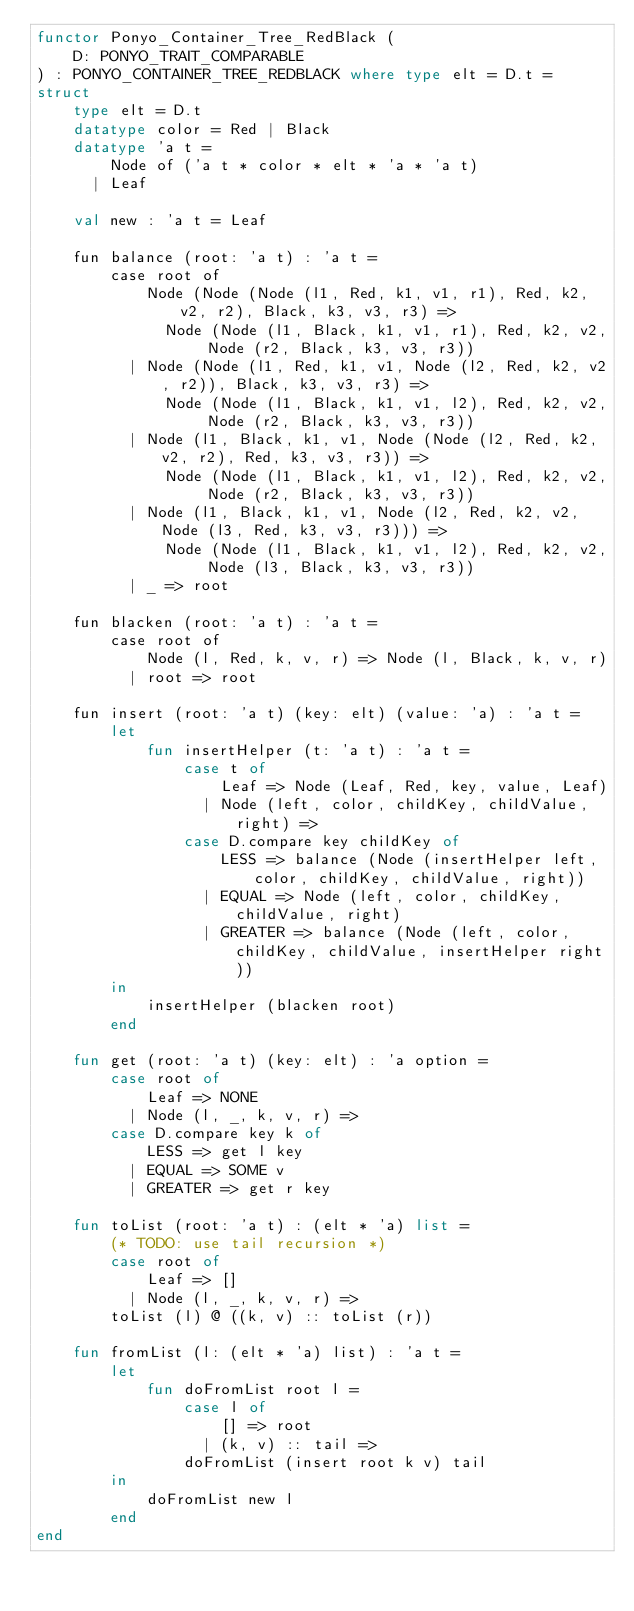<code> <loc_0><loc_0><loc_500><loc_500><_SML_>functor Ponyo_Container_Tree_RedBlack (
    D: PONYO_TRAIT_COMPARABLE
) : PONYO_CONTAINER_TREE_REDBLACK where type elt = D.t =
struct
    type elt = D.t
    datatype color = Red | Black
    datatype 'a t =
        Node of ('a t * color * elt * 'a * 'a t)
      | Leaf

    val new : 'a t = Leaf

    fun balance (root: 'a t) : 'a t =
        case root of
            Node (Node (Node (l1, Red, k1, v1, r1), Red, k2, v2, r2), Black, k3, v3, r3) =>
              Node (Node (l1, Black, k1, v1, r1), Red, k2, v2, Node (r2, Black, k3, v3, r3))
          | Node (Node (l1, Red, k1, v1, Node (l2, Red, k2, v2, r2)), Black, k3, v3, r3) =>
              Node (Node (l1, Black, k1, v1, l2), Red, k2, v2, Node (r2, Black, k3, v3, r3))
          | Node (l1, Black, k1, v1, Node (Node (l2, Red, k2, v2, r2), Red, k3, v3, r3)) =>
              Node (Node (l1, Black, k1, v1, l2), Red, k2, v2, Node (r2, Black, k3, v3, r3))
          | Node (l1, Black, k1, v1, Node (l2, Red, k2, v2, Node (l3, Red, k3, v3, r3))) =>
              Node (Node (l1, Black, k1, v1, l2), Red, k2, v2, Node (l3, Black, k3, v3, r3))
          | _ => root

    fun blacken (root: 'a t) : 'a t =
        case root of
            Node (l, Red, k, v, r) => Node (l, Black, k, v, r)
          | root => root

    fun insert (root: 'a t) (key: elt) (value: 'a) : 'a t =
        let
            fun insertHelper (t: 'a t) : 'a t =
                case t of
                    Leaf => Node (Leaf, Red, key, value, Leaf)
                  | Node (left, color, childKey, childValue, right) =>
                case D.compare key childKey of
                    LESS => balance (Node (insertHelper left, color, childKey, childValue, right))
                  | EQUAL => Node (left, color, childKey, childValue, right)
                  | GREATER => balance (Node (left, color, childKey, childValue, insertHelper right))
        in
            insertHelper (blacken root)
        end

    fun get (root: 'a t) (key: elt) : 'a option =
        case root of
            Leaf => NONE
          | Node (l, _, k, v, r) =>
        case D.compare key k of
            LESS => get l key
          | EQUAL => SOME v
          | GREATER => get r key

    fun toList (root: 'a t) : (elt * 'a) list =
        (* TODO: use tail recursion *)
        case root of
            Leaf => []
          | Node (l, _, k, v, r) =>
        toList (l) @ ((k, v) :: toList (r))

    fun fromList (l: (elt * 'a) list) : 'a t =
        let
            fun doFromList root l =
                case l of
                    [] => root
                  | (k, v) :: tail =>
                doFromList (insert root k v) tail
        in
            doFromList new l
        end
end
</code> 